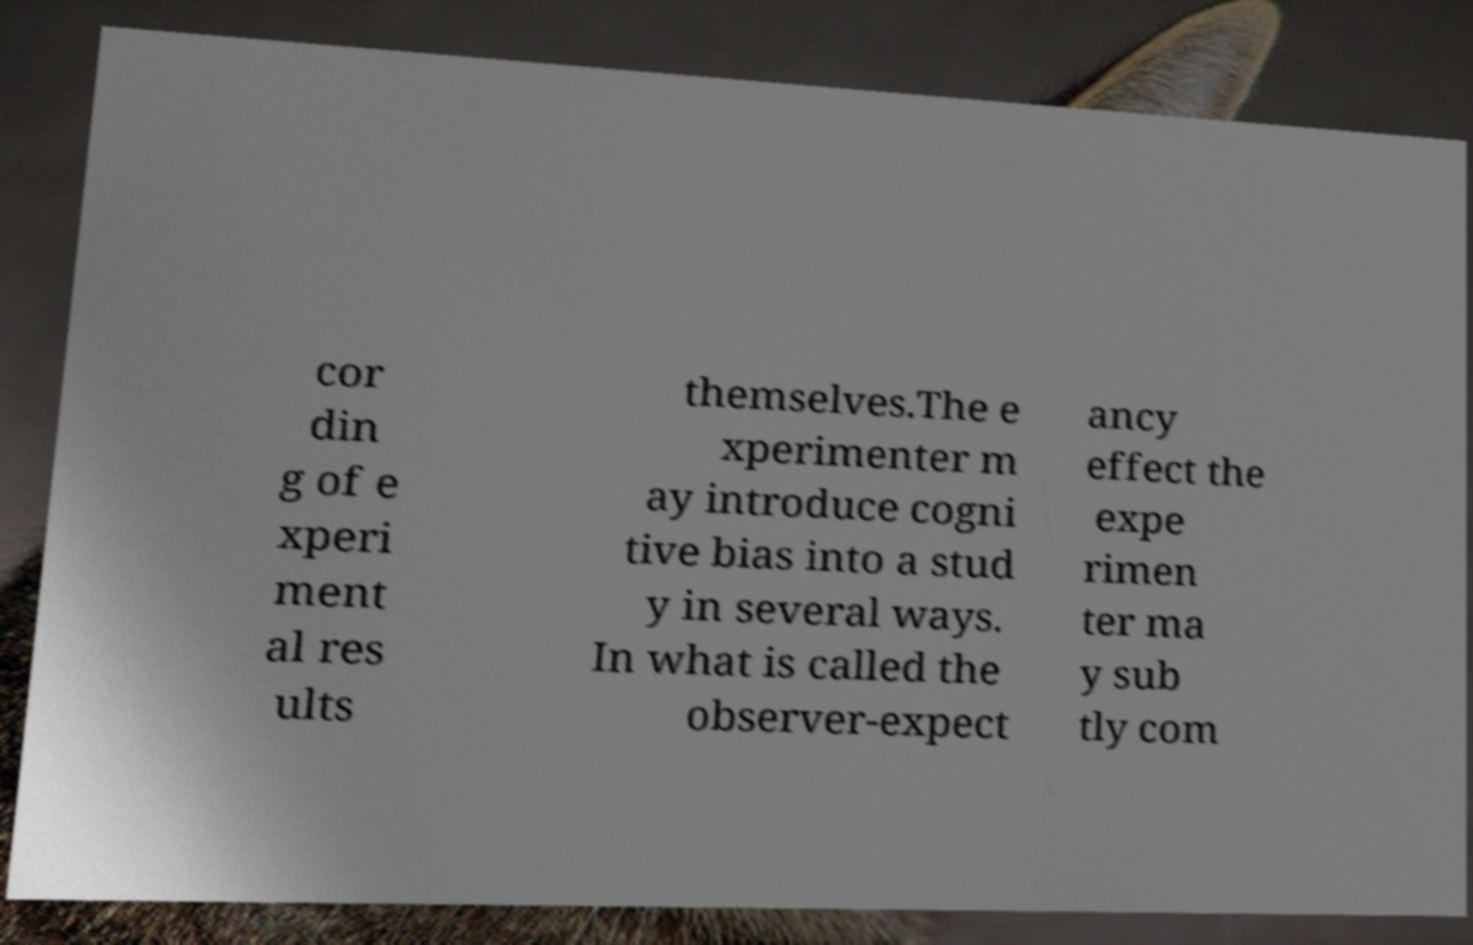I need the written content from this picture converted into text. Can you do that? cor din g of e xperi ment al res ults themselves.The e xperimenter m ay introduce cogni tive bias into a stud y in several ways. In what is called the observer-expect ancy effect the expe rimen ter ma y sub tly com 